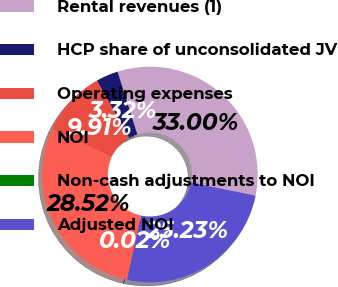Convert chart. <chart><loc_0><loc_0><loc_500><loc_500><pie_chart><fcel>Rental revenues (1)<fcel>HCP share of unconsolidated JV<fcel>Operating expenses<fcel>NOI<fcel>Non-cash adjustments to NOI<fcel>Adjusted NOI<nl><fcel>33.0%<fcel>3.32%<fcel>9.91%<fcel>28.52%<fcel>0.02%<fcel>25.23%<nl></chart> 